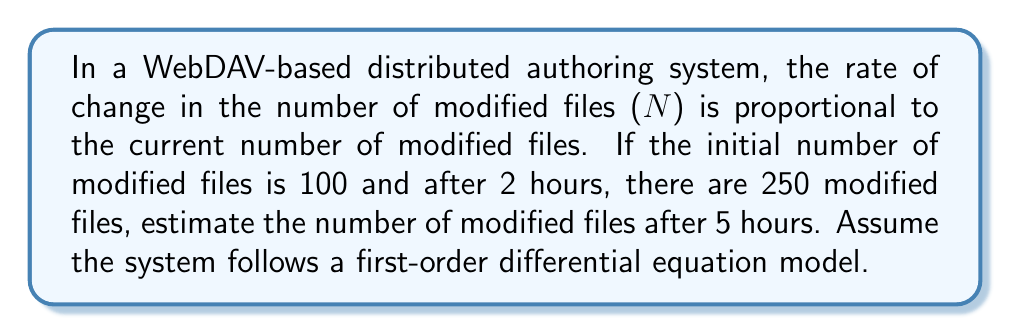Could you help me with this problem? Let's approach this step-by-step:

1) The given information fits a first-order differential equation model:

   $$\frac{dN}{dt} = kN$$

   where $N$ is the number of modified files, $t$ is time in hours, and $k$ is the proportionality constant.

2) The solution to this differential equation is:

   $$N(t) = N_0e^{kt}$$

   where $N_0$ is the initial number of modified files.

3) We're given:
   - $N_0 = 100$ (initial number of modified files)
   - $N(2) = 250$ (after 2 hours)

4) Let's find $k$ using the information at $t=2$:

   $$250 = 100e^{2k}$$

5) Solving for $k$:

   $$e^{2k} = 2.5$$
   $$2k = \ln(2.5)$$
   $$k = \frac{\ln(2.5)}{2} \approx 0.4576$$

6) Now that we have $k$, we can use the equation to find $N(5)$:

   $$N(5) = 100e^{0.4576 * 5}$$

7) Calculating this:

   $$N(5) = 100e^{2.288} \approx 990.17$$

Therefore, after 5 hours, we estimate there will be approximately 990 modified files.
Answer: After 5 hours, there will be approximately 990 modified files in the WebDAV-based distributed authoring system. 